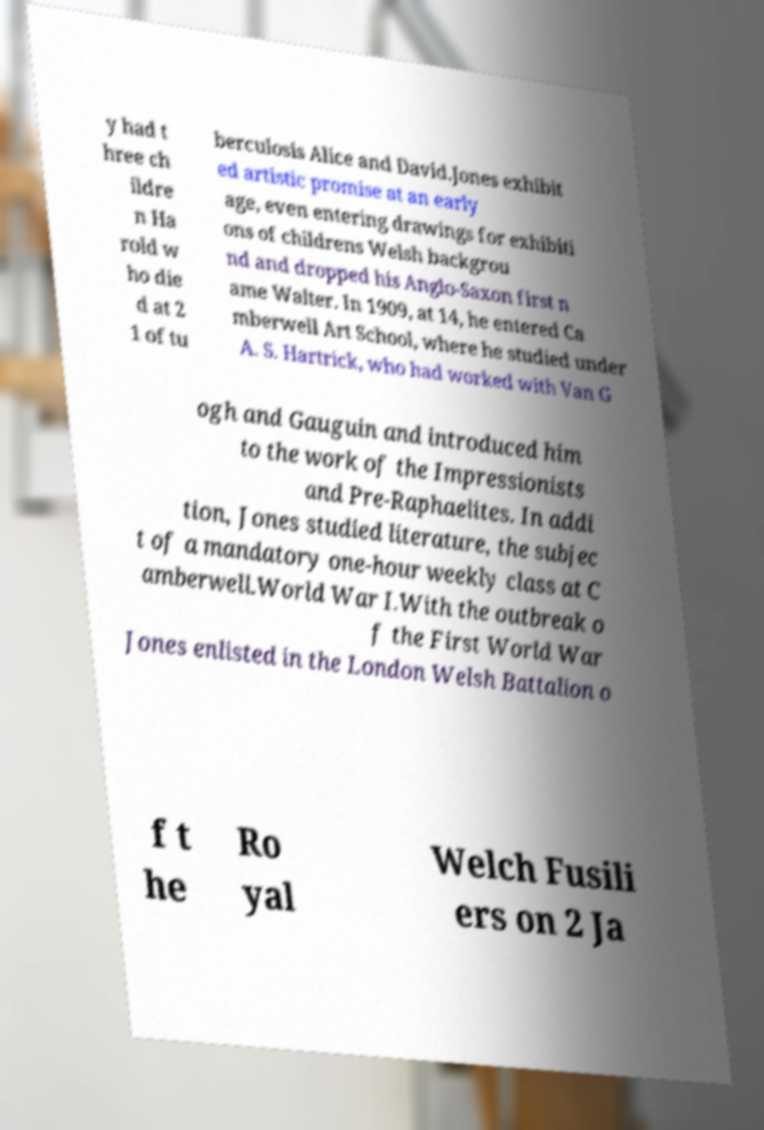Please identify and transcribe the text found in this image. y had t hree ch ildre n Ha rold w ho die d at 2 1 of tu berculosis Alice and David.Jones exhibit ed artistic promise at an early age, even entering drawings for exhibiti ons of childrens Welsh backgrou nd and dropped his Anglo-Saxon first n ame Walter. In 1909, at 14, he entered Ca mberwell Art School, where he studied under A. S. Hartrick, who had worked with Van G ogh and Gauguin and introduced him to the work of the Impressionists and Pre-Raphaelites. In addi tion, Jones studied literature, the subjec t of a mandatory one-hour weekly class at C amberwell.World War I.With the outbreak o f the First World War Jones enlisted in the London Welsh Battalion o f t he Ro yal Welch Fusili ers on 2 Ja 